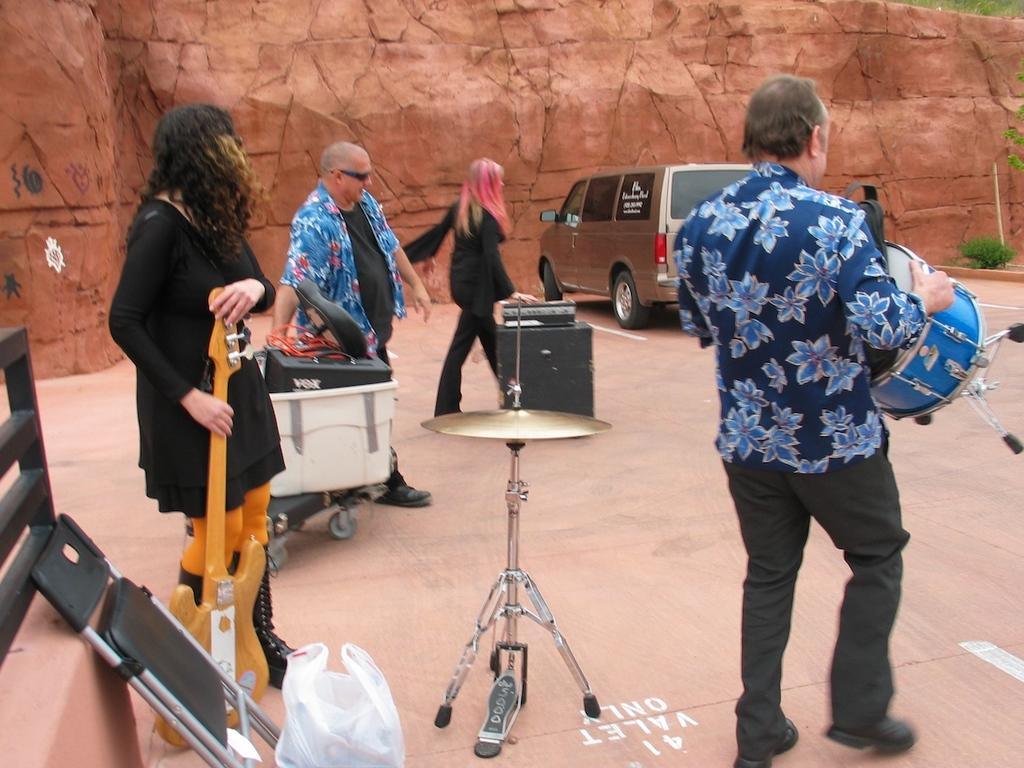What are the persons in the image doing? In the image, a man is playing a drum, and a woman is holding a guitar. What type of objects are the persons holding? The persons are holding musical instruments, specifically a drum and a guitar. What can be seen in the distance in the image? There is a vehicle in the distance. What is the container with things in it used for? The purpose of the container with things in it is not specified in the facts provided. What type of creature is playing the guitar in the image? There is no creature present in the image; the guitar is being held by a woman. Where can the persons in the image purchase a meal? The facts provided do not mention a store or a meal, so it cannot be determined from the image. 